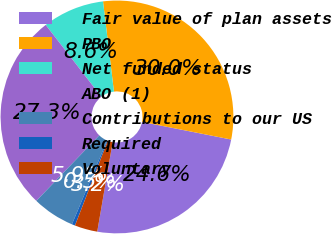<chart> <loc_0><loc_0><loc_500><loc_500><pie_chart><fcel>Fair value of plan assets<fcel>PBO<fcel>Net funded status<fcel>ABO (1)<fcel>Contributions to our US<fcel>Required<fcel>Voluntary<nl><fcel>24.61%<fcel>30.02%<fcel>8.57%<fcel>27.32%<fcel>5.86%<fcel>0.45%<fcel>3.16%<nl></chart> 